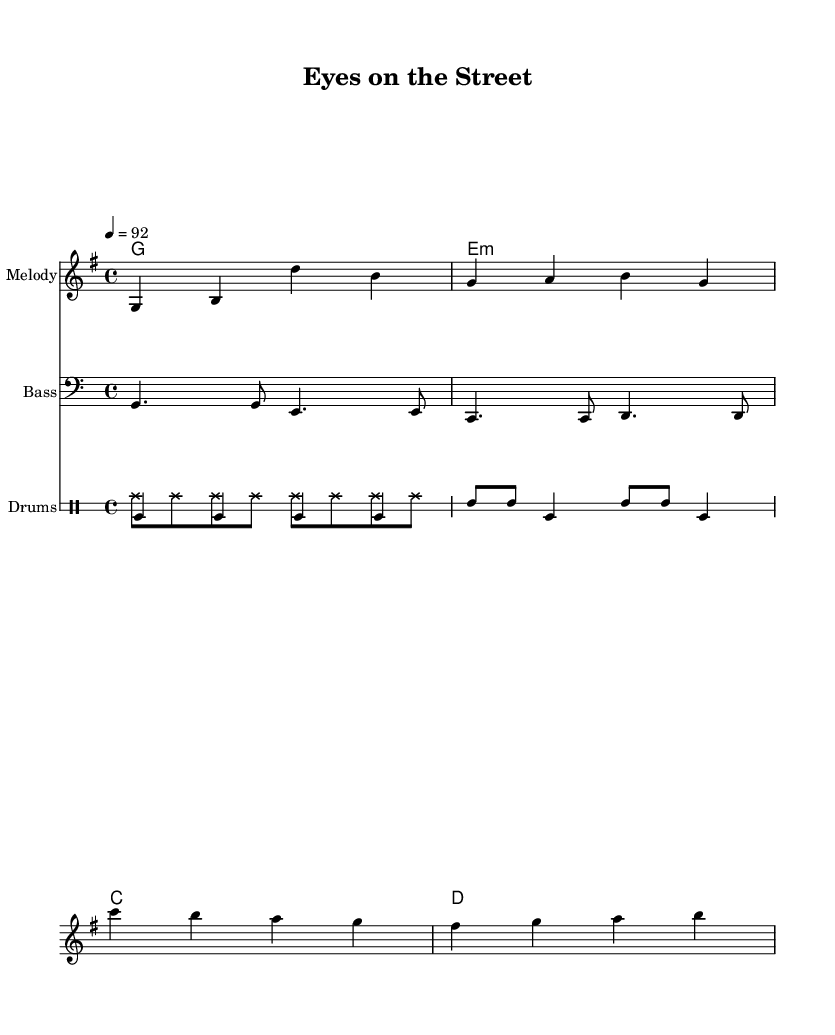What is the key signature of this music? The key signature shown is G major, which has one sharp (F#). This can be identified at the beginning of the sheet music in the key signature indication.
Answer: G major What is the time signature of this music? The time signature is 4/4, indicated at the beginning of the music sheet. This means there are four beats per measure with the quarter note receiving one beat.
Answer: 4/4 What is the tempo marking for this piece? The tempo marking is 92 beats per minute (bpm), which is indicated in the score through the tempo directive shown at the beginning.
Answer: 92 How many measures are there in the melody? The melody consists of 4 measures, which can be counted by observing the number of vertical bar lines present in the melody staff.
Answer: 4 What type of lyrics are featured in this piece? The lyrics featured are primarily community-oriented and promote cooperation among individuals to ensure safety, as indicated in the lyrical text that encourages unity.
Answer: Community-oriented How do the drum patterns contribute to the reggae feel? The drum patterns demonstrate a typical reggae feel by using consistent bass drum and snare strikes that emphasize off-beats, common in reggae music, creating a laid-back yet rhythmic groove.
Answer: Off-beats What instruments are used in this composition? The composition includes melody, bass, and drums, distinguished by the separate staffs allocated in the score for each instrumental part.
Answer: Melody, bass, drums 